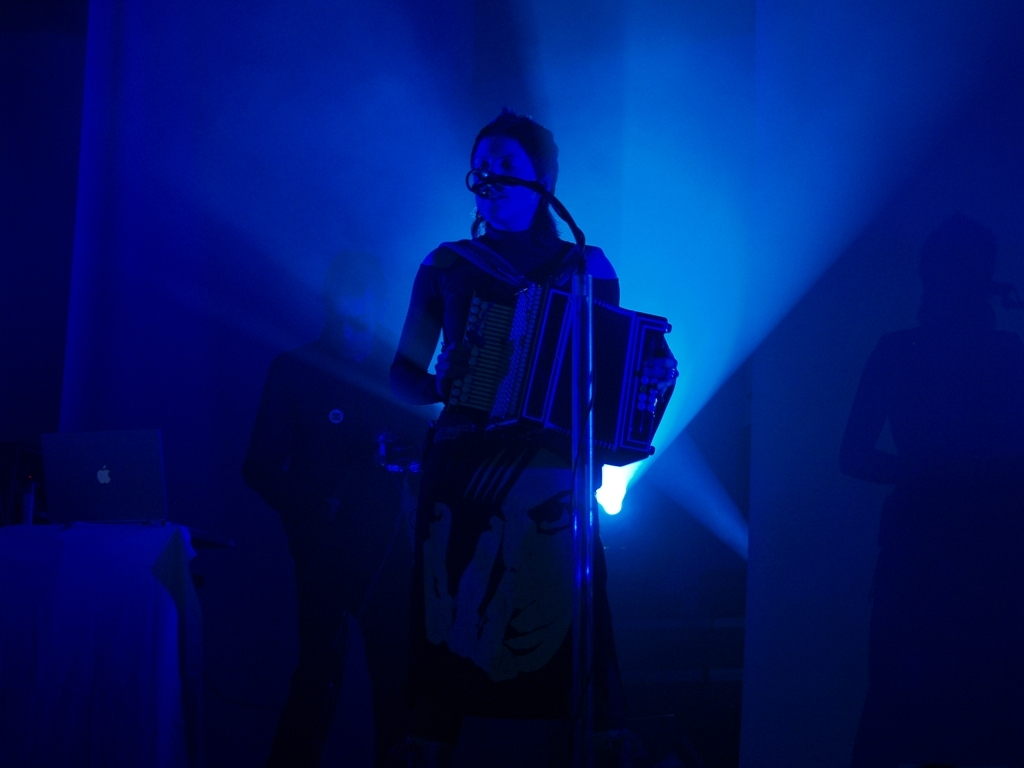Is the subject of the image two people playing music? The image shows only one person, who appears to be playing an accordion, illuminated by stage lighting with a moody atmosphere. There is no clear evidence of another person playing music alongside them. 